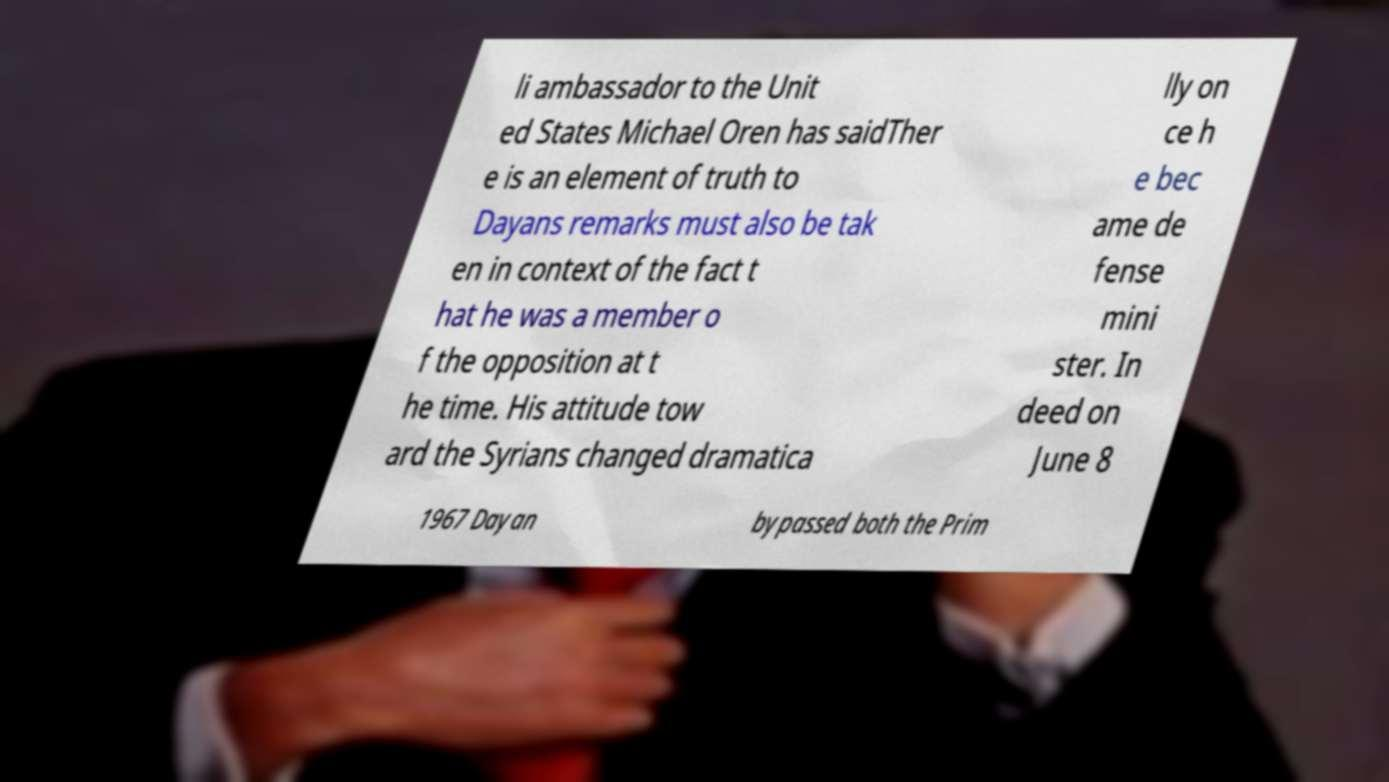For documentation purposes, I need the text within this image transcribed. Could you provide that? li ambassador to the Unit ed States Michael Oren has saidTher e is an element of truth to Dayans remarks must also be tak en in context of the fact t hat he was a member o f the opposition at t he time. His attitude tow ard the Syrians changed dramatica lly on ce h e bec ame de fense mini ster. In deed on June 8 1967 Dayan bypassed both the Prim 